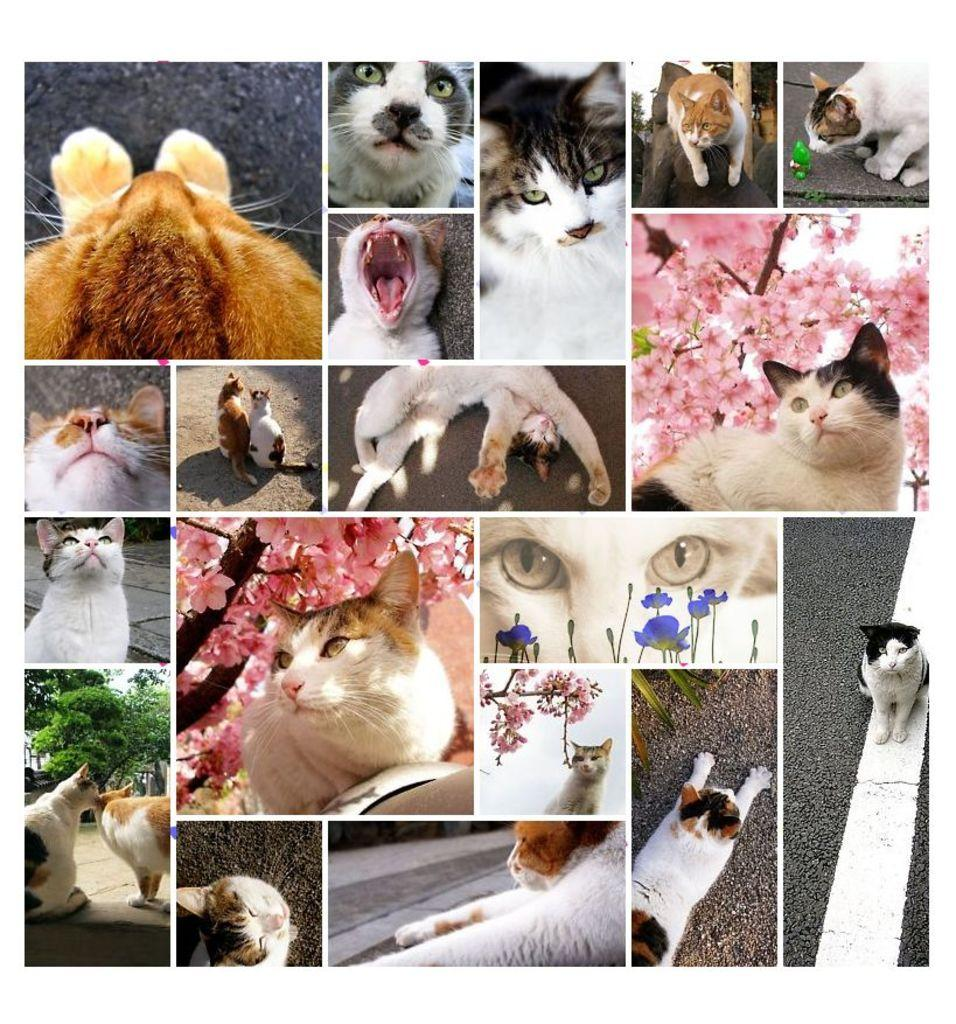What type of artwork is depicted in the image? The image is a collage. What types of images can be found in the collage? There are pictures of cats, flowers, trees, and roads in the collage. How many ducks are swimming in the cream in the middle of the image? There are no ducks or cream present in the image; it is a collage featuring pictures of cats, flowers, trees, and roads. 